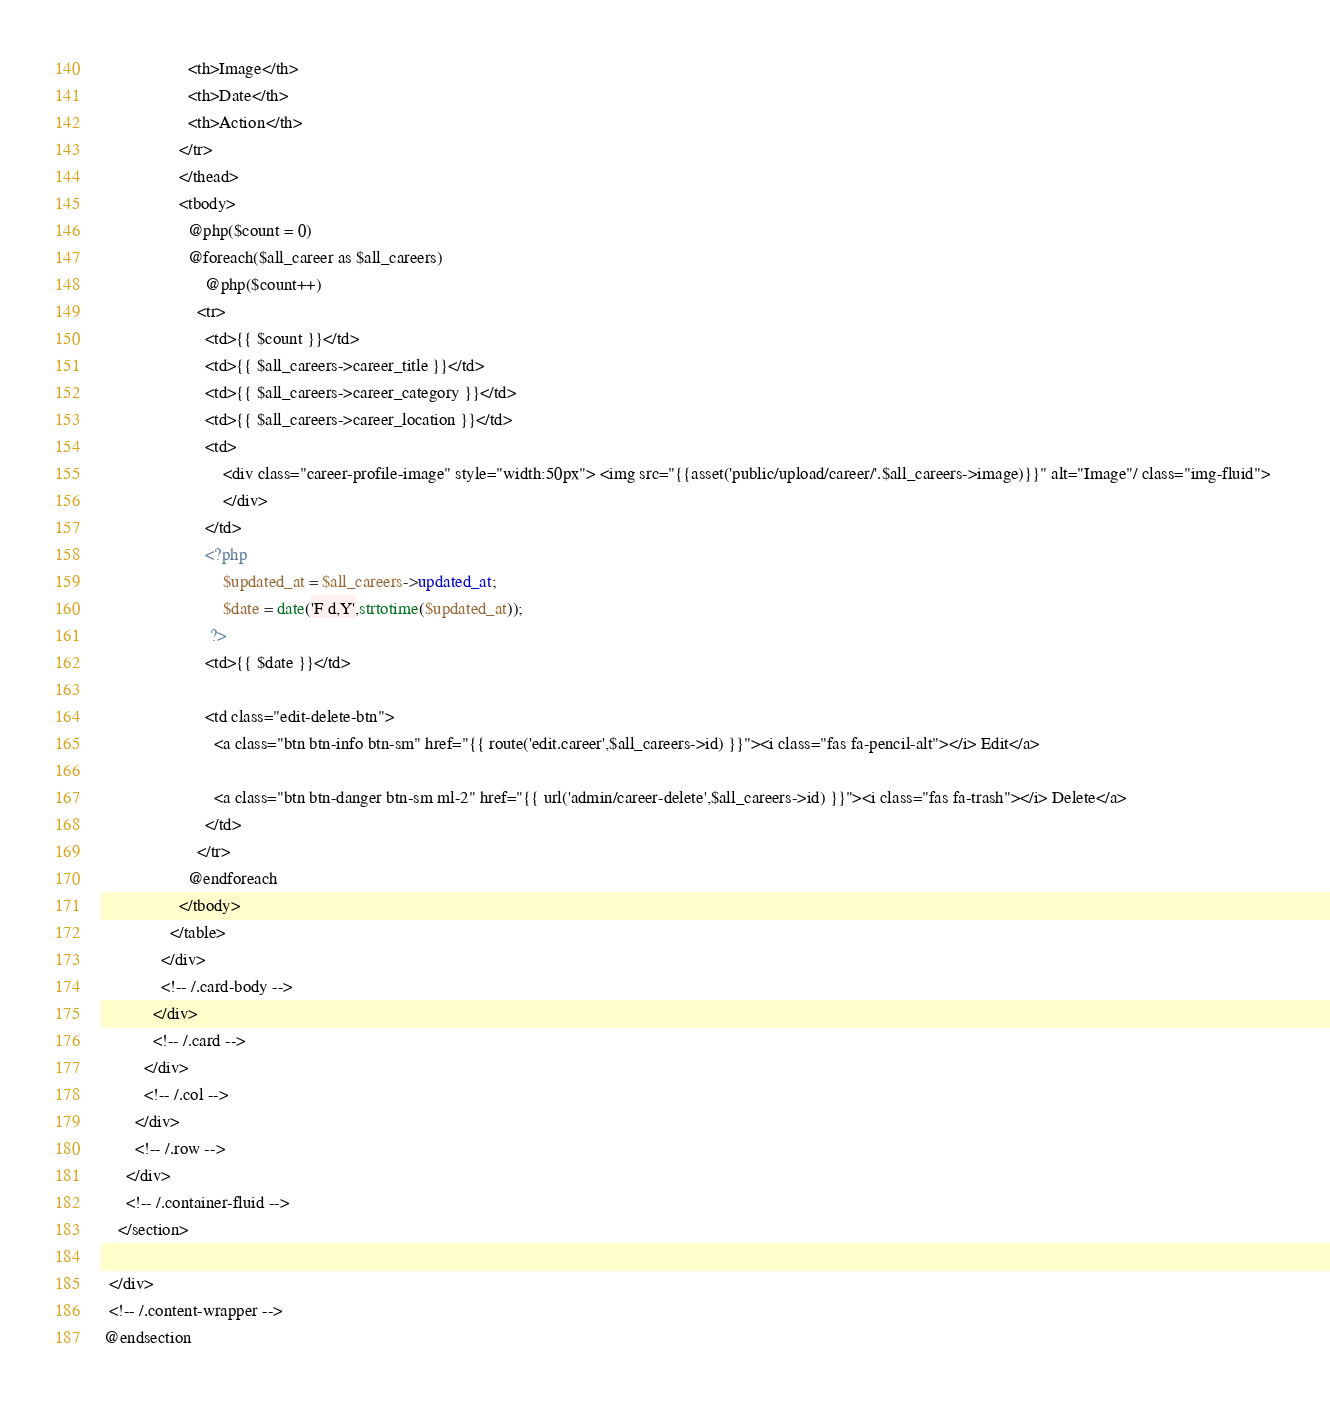<code> <loc_0><loc_0><loc_500><loc_500><_PHP_>                    <th>Image</th>
                    <th>Date</th>
                    <th>Action</th>
                  </tr>
                  </thead>
                  <tbody>
                    @php($count = 0)
                    @foreach($all_career as $all_careers)
                        @php($count++)
                      <tr>
                        <td>{{ $count }}</td>
                        <td>{{ $all_careers->career_title }}</td>
                        <td>{{ $all_careers->career_category }}</td>
                        <td>{{ $all_careers->career_location }}</td>
                        <td>
                        	<div class="career-profile-image" style="width:50px"> <img src="{{asset('public/upload/career/'.$all_careers->image)}}" alt="Image"/ class="img-fluid"> 
                        	</div>
                        </td>
                        <?php
                        	$updated_at = $all_careers->updated_at;
                        	$date = date('F d,Y',strtotime($updated_at));
                         ?>
                        <td>{{ $date }}</td>

                        <td class="edit-delete-btn">
                          <a class="btn btn-info btn-sm" href="{{ route('edit.career',$all_careers->id) }}"><i class="fas fa-pencil-alt"></i> Edit</a> 

                          <a class="btn btn-danger btn-sm ml-2" href="{{ url('admin/career-delete',$all_careers->id) }}"><i class="fas fa-trash"></i> Delete</a>
                        </td>
                      </tr>
                    @endforeach
                  </tbody>
                </table>
              </div>
              <!-- /.card-body -->
            </div>
            <!-- /.card -->
          </div>
          <!-- /.col -->
        </div>
        <!-- /.row -->
      </div>
      <!-- /.container-fluid -->
    </section>

  </div>
  <!-- /.content-wrapper -->
 @endsection
</code> 